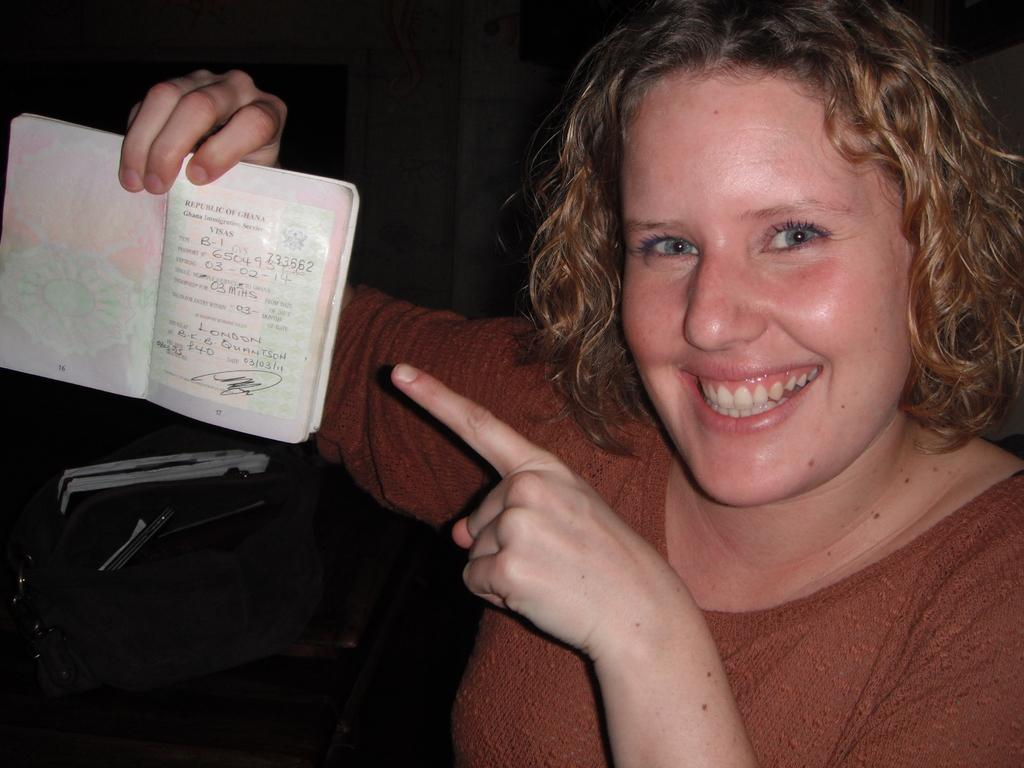Who is present in the image? There is a woman in the image. What is the woman doing in the image? The woman is smiling and holding a book. What can be seen on the left side of the woman? There are objects on the left side of the woman. How would you describe the background of the image? The background of the image is dark. What type of fish can be seen swimming in the background of the image? There are no fish present in the image; the background is dark. 